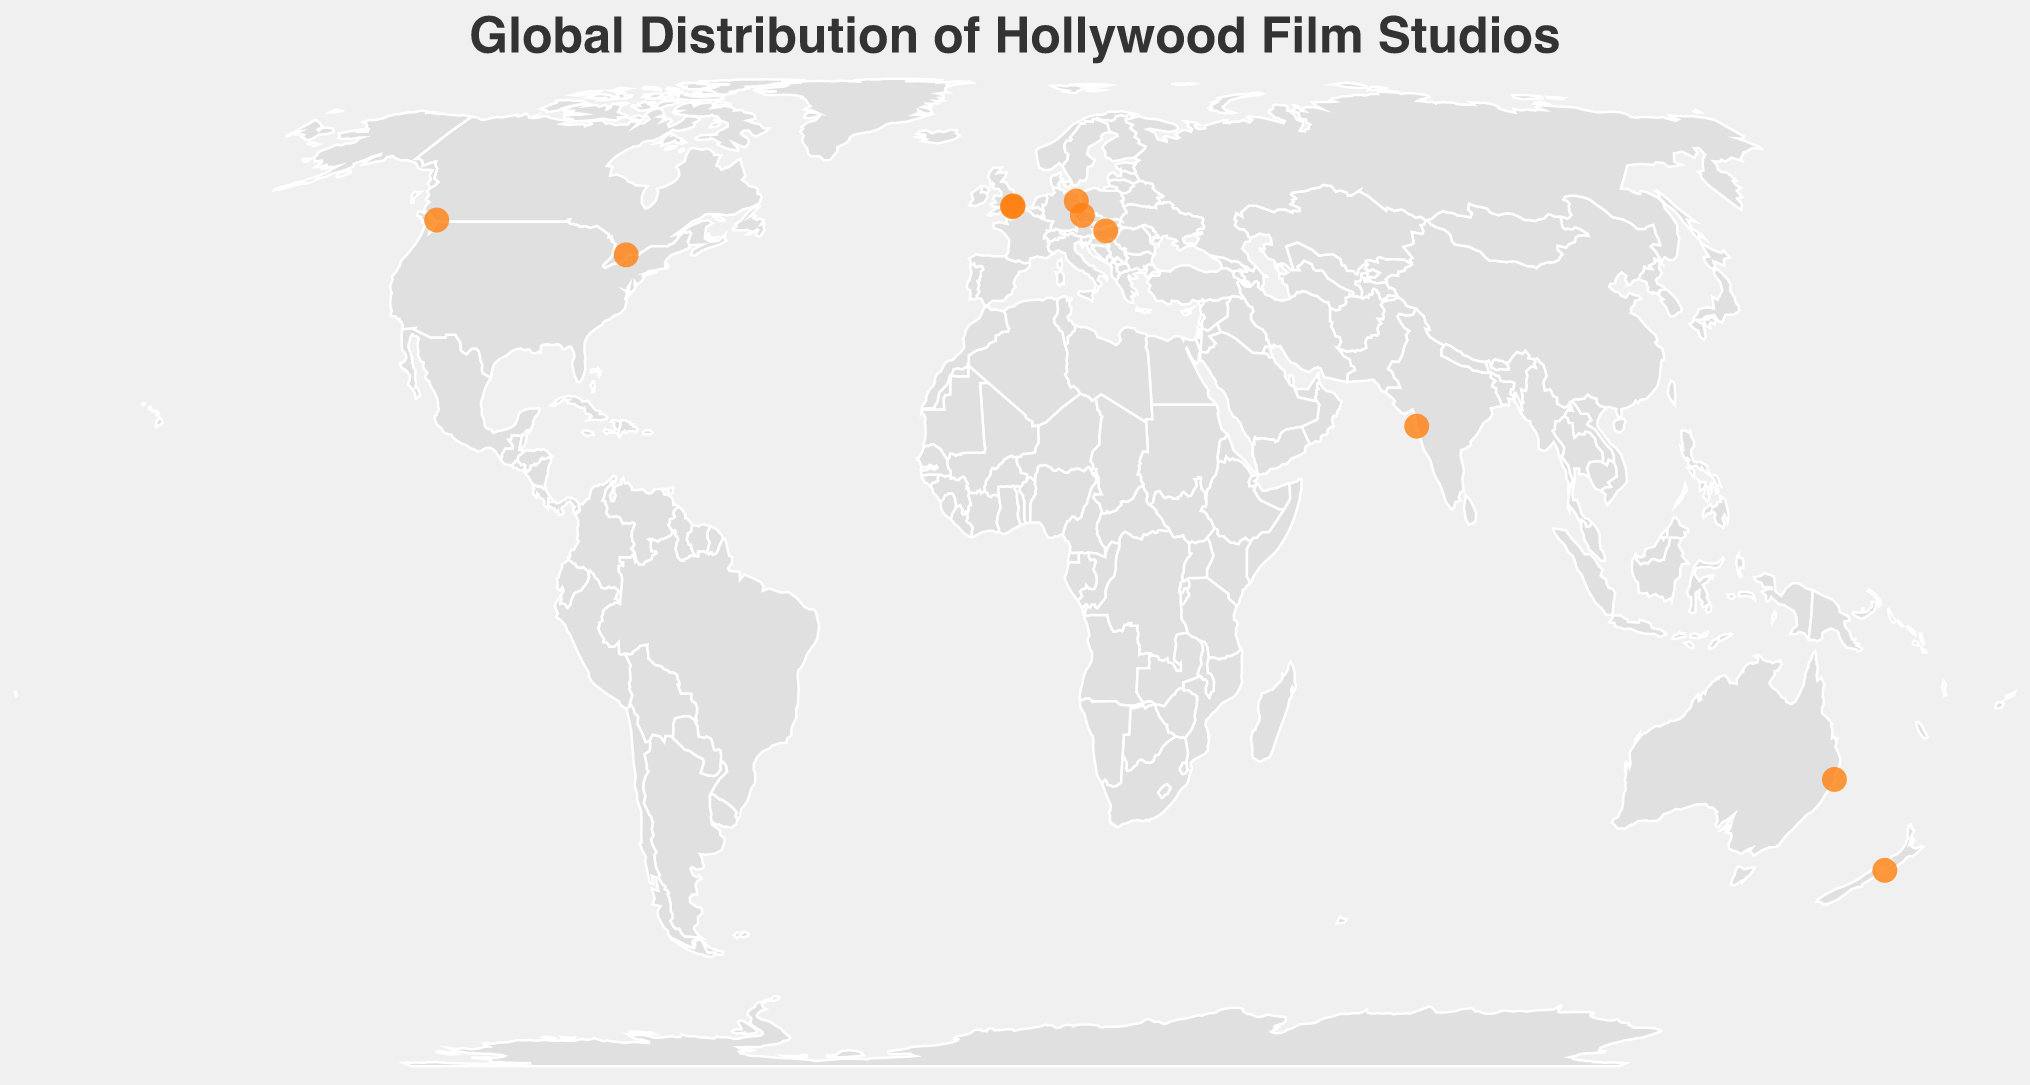What is the title of the plot? The title is usually located at the top of the plot and in this case, it's specified in the data provided.
Answer: Global Distribution of Hollywood Film Studios Which studio has an international production location in Toronto, Canada? Locate the point representing Toronto, Canada on the plot and identify the studio from the tooltip.
Answer: Paramount Pictures How many studios have their headquarters in Burbank, CA, USA? Identify all the points that mention "Burbank CA USA" as their headquarters.
Answer: 3 studios: Warner Bros., Walt Disney Studios, New Line Cinema What is the furthest production location from Los Angeles, CA, USA? Measure the distance between Los Angeles and all international production locations and find the maximum.
Answer: Wellington, New Zealand Which studio's international production location is in Berlin, Germany? Find the point on the map representing Berlin, Germany and check the tooltip for the studio.
Answer: Sony Pictures Compare the number of international production locations in Europe versus North America. Which continent has more? Identify and count all the international production locations in each continent from the figure.
Answer: Europe has 4, North America has 2. Europe has more Which two studios have international production locations in the UK? Find the points representing locations in the UK and identify the studios from the tooltip.
Answer: Warner Bros. and Walt Disney Studios What type of projection is used for this geographic plot? The type of projection can often be found in the title or description of the plot.
Answer: Equal Earth What is the common color used for the points representing production locations? The color of the points can be observed visually from the figure.
Answer: Orange Which studio has an international production location closest to its headquarters in terms of geographical distance? Measure the geographical distance between each headquarters and its corresponding international production location and identify the smallest.
Answer: Lionsgate (Vancouver, Canada to Santa Monica, CA, USA) 